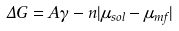<formula> <loc_0><loc_0><loc_500><loc_500>\Delta G = A \gamma - n | \mu _ { s o l } - \mu _ { m f } |</formula> 